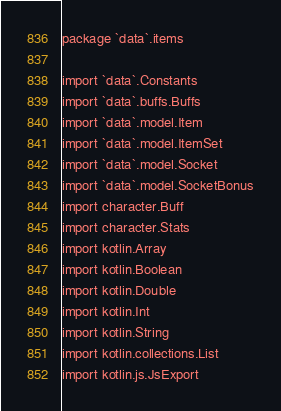Convert code to text. <code><loc_0><loc_0><loc_500><loc_500><_Kotlin_>package `data`.items

import `data`.Constants
import `data`.buffs.Buffs
import `data`.model.Item
import `data`.model.ItemSet
import `data`.model.Socket
import `data`.model.SocketBonus
import character.Buff
import character.Stats
import kotlin.Array
import kotlin.Boolean
import kotlin.Double
import kotlin.Int
import kotlin.String
import kotlin.collections.List
import kotlin.js.JsExport
</code> 